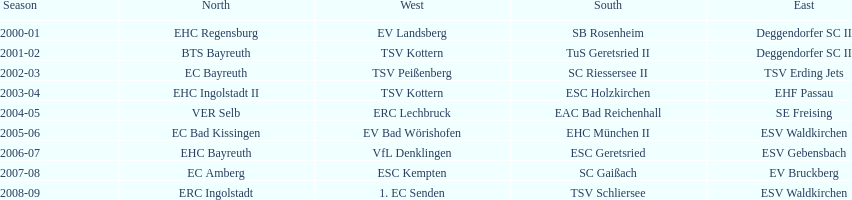Starting with the 2007 - 08 season, does ecs kempten appear in any of the previous years? No. 